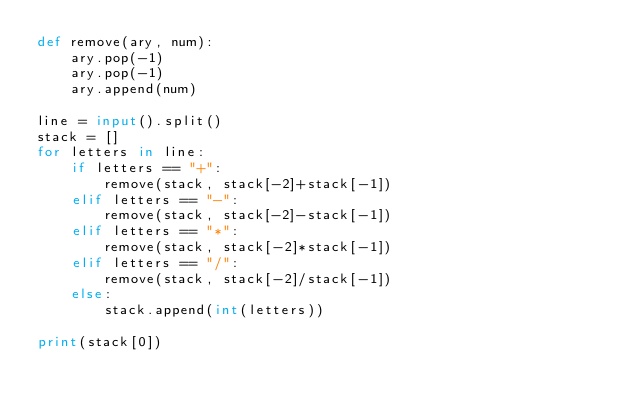Convert code to text. <code><loc_0><loc_0><loc_500><loc_500><_Python_>def remove(ary, num):
    ary.pop(-1)
    ary.pop(-1)
    ary.append(num)

line = input().split()
stack = []
for letters in line:
    if letters == "+":
        remove(stack, stack[-2]+stack[-1])
    elif letters == "-":
        remove(stack, stack[-2]-stack[-1])
    elif letters == "*":
        remove(stack, stack[-2]*stack[-1])
    elif letters == "/":
        remove(stack, stack[-2]/stack[-1])
    else:
        stack.append(int(letters))

print(stack[0])

</code> 